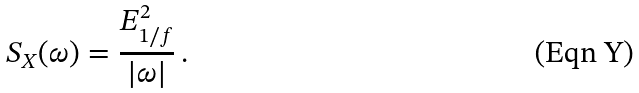<formula> <loc_0><loc_0><loc_500><loc_500>S _ { X } ( \omega ) = \frac { E _ { 1 / f } ^ { 2 } } { | \omega | } \, .</formula> 